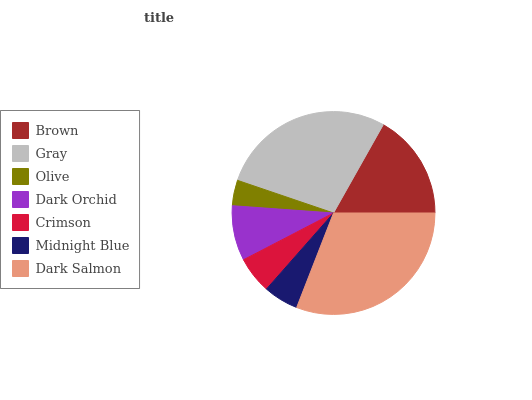Is Olive the minimum?
Answer yes or no. Yes. Is Dark Salmon the maximum?
Answer yes or no. Yes. Is Gray the minimum?
Answer yes or no. No. Is Gray the maximum?
Answer yes or no. No. Is Gray greater than Brown?
Answer yes or no. Yes. Is Brown less than Gray?
Answer yes or no. Yes. Is Brown greater than Gray?
Answer yes or no. No. Is Gray less than Brown?
Answer yes or no. No. Is Dark Orchid the high median?
Answer yes or no. Yes. Is Dark Orchid the low median?
Answer yes or no. Yes. Is Gray the high median?
Answer yes or no. No. Is Crimson the low median?
Answer yes or no. No. 